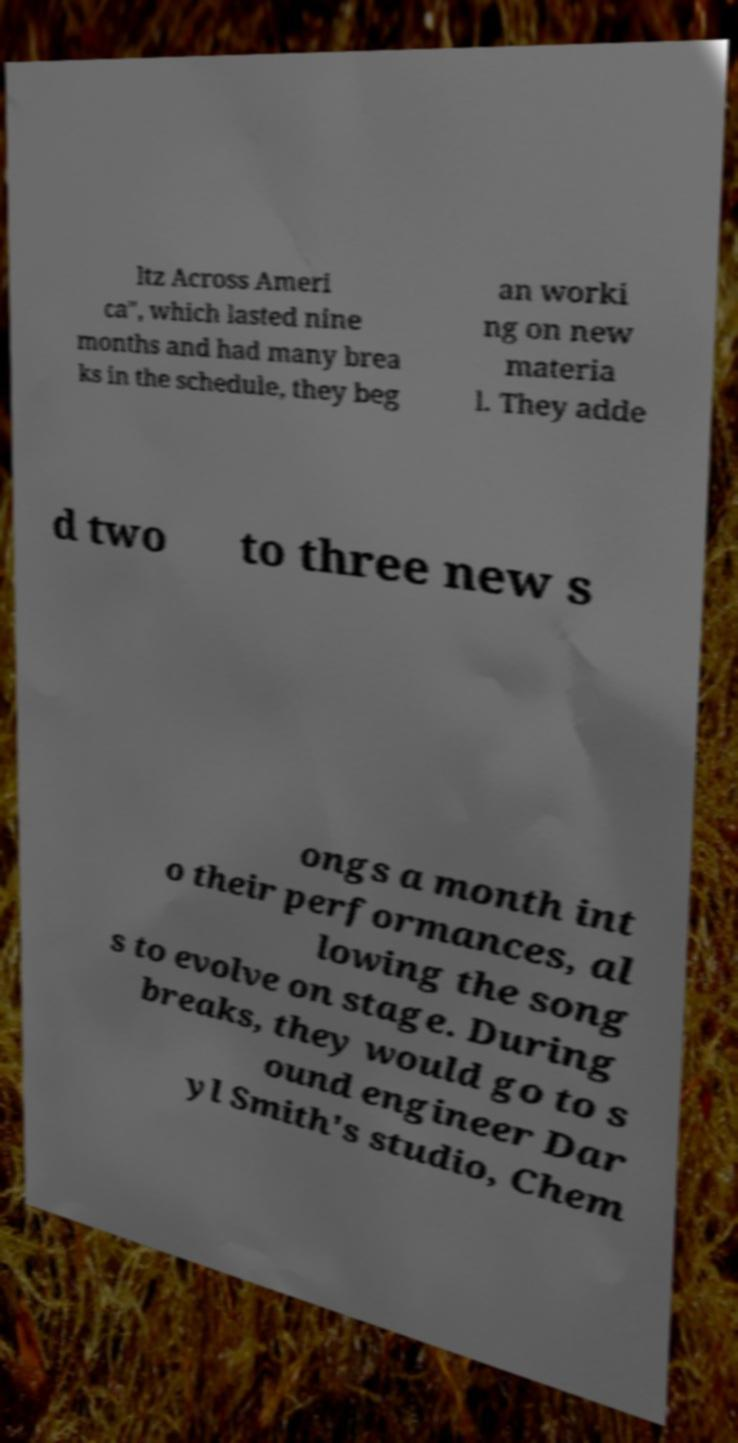Can you read and provide the text displayed in the image?This photo seems to have some interesting text. Can you extract and type it out for me? ltz Across Ameri ca", which lasted nine months and had many brea ks in the schedule, they beg an worki ng on new materia l. They adde d two to three new s ongs a month int o their performances, al lowing the song s to evolve on stage. During breaks, they would go to s ound engineer Dar yl Smith's studio, Chem 